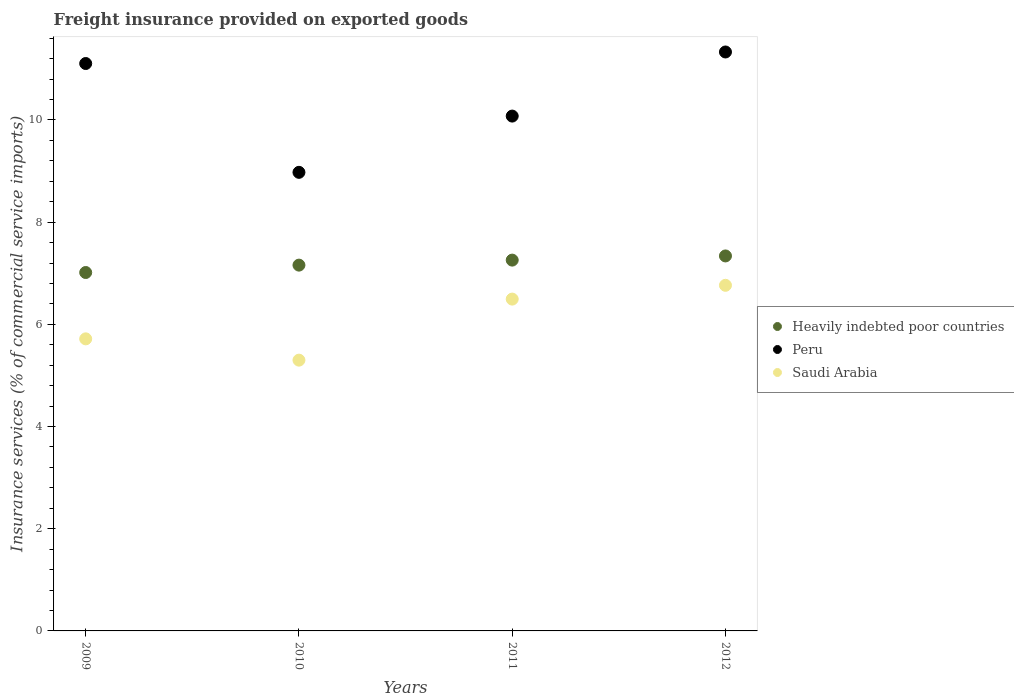How many different coloured dotlines are there?
Offer a very short reply. 3. Is the number of dotlines equal to the number of legend labels?
Offer a terse response. Yes. What is the freight insurance provided on exported goods in Peru in 2009?
Your response must be concise. 11.1. Across all years, what is the maximum freight insurance provided on exported goods in Heavily indebted poor countries?
Offer a very short reply. 7.34. Across all years, what is the minimum freight insurance provided on exported goods in Peru?
Keep it short and to the point. 8.98. In which year was the freight insurance provided on exported goods in Heavily indebted poor countries minimum?
Your response must be concise. 2009. What is the total freight insurance provided on exported goods in Saudi Arabia in the graph?
Give a very brief answer. 24.27. What is the difference between the freight insurance provided on exported goods in Peru in 2011 and that in 2012?
Give a very brief answer. -1.25. What is the difference between the freight insurance provided on exported goods in Saudi Arabia in 2011 and the freight insurance provided on exported goods in Heavily indebted poor countries in 2012?
Your response must be concise. -0.84. What is the average freight insurance provided on exported goods in Saudi Arabia per year?
Offer a very short reply. 6.07. In the year 2011, what is the difference between the freight insurance provided on exported goods in Peru and freight insurance provided on exported goods in Heavily indebted poor countries?
Provide a succinct answer. 2.82. What is the ratio of the freight insurance provided on exported goods in Peru in 2009 to that in 2011?
Provide a short and direct response. 1.1. What is the difference between the highest and the second highest freight insurance provided on exported goods in Peru?
Give a very brief answer. 0.23. What is the difference between the highest and the lowest freight insurance provided on exported goods in Peru?
Your response must be concise. 2.36. In how many years, is the freight insurance provided on exported goods in Saudi Arabia greater than the average freight insurance provided on exported goods in Saudi Arabia taken over all years?
Provide a short and direct response. 2. Is it the case that in every year, the sum of the freight insurance provided on exported goods in Peru and freight insurance provided on exported goods in Saudi Arabia  is greater than the freight insurance provided on exported goods in Heavily indebted poor countries?
Provide a succinct answer. Yes. Does the freight insurance provided on exported goods in Peru monotonically increase over the years?
Your response must be concise. No. Is the freight insurance provided on exported goods in Peru strictly less than the freight insurance provided on exported goods in Heavily indebted poor countries over the years?
Offer a very short reply. No. How many dotlines are there?
Provide a succinct answer. 3. What is the difference between two consecutive major ticks on the Y-axis?
Give a very brief answer. 2. Does the graph contain any zero values?
Make the answer very short. No. Where does the legend appear in the graph?
Offer a very short reply. Center right. How are the legend labels stacked?
Your answer should be very brief. Vertical. What is the title of the graph?
Your response must be concise. Freight insurance provided on exported goods. Does "Guam" appear as one of the legend labels in the graph?
Your response must be concise. No. What is the label or title of the Y-axis?
Give a very brief answer. Insurance services (% of commercial service imports). What is the Insurance services (% of commercial service imports) in Heavily indebted poor countries in 2009?
Provide a succinct answer. 7.01. What is the Insurance services (% of commercial service imports) of Peru in 2009?
Your answer should be compact. 11.1. What is the Insurance services (% of commercial service imports) of Saudi Arabia in 2009?
Your answer should be very brief. 5.72. What is the Insurance services (% of commercial service imports) in Heavily indebted poor countries in 2010?
Your answer should be compact. 7.16. What is the Insurance services (% of commercial service imports) of Peru in 2010?
Give a very brief answer. 8.98. What is the Insurance services (% of commercial service imports) in Saudi Arabia in 2010?
Your answer should be compact. 5.3. What is the Insurance services (% of commercial service imports) in Heavily indebted poor countries in 2011?
Offer a terse response. 7.26. What is the Insurance services (% of commercial service imports) of Peru in 2011?
Make the answer very short. 10.08. What is the Insurance services (% of commercial service imports) of Saudi Arabia in 2011?
Make the answer very short. 6.49. What is the Insurance services (% of commercial service imports) in Heavily indebted poor countries in 2012?
Make the answer very short. 7.34. What is the Insurance services (% of commercial service imports) of Peru in 2012?
Give a very brief answer. 11.33. What is the Insurance services (% of commercial service imports) of Saudi Arabia in 2012?
Provide a succinct answer. 6.76. Across all years, what is the maximum Insurance services (% of commercial service imports) in Heavily indebted poor countries?
Give a very brief answer. 7.34. Across all years, what is the maximum Insurance services (% of commercial service imports) of Peru?
Your answer should be compact. 11.33. Across all years, what is the maximum Insurance services (% of commercial service imports) of Saudi Arabia?
Your answer should be compact. 6.76. Across all years, what is the minimum Insurance services (% of commercial service imports) in Heavily indebted poor countries?
Your answer should be compact. 7.01. Across all years, what is the minimum Insurance services (% of commercial service imports) in Peru?
Provide a succinct answer. 8.98. Across all years, what is the minimum Insurance services (% of commercial service imports) in Saudi Arabia?
Give a very brief answer. 5.3. What is the total Insurance services (% of commercial service imports) in Heavily indebted poor countries in the graph?
Offer a terse response. 28.77. What is the total Insurance services (% of commercial service imports) in Peru in the graph?
Keep it short and to the point. 41.49. What is the total Insurance services (% of commercial service imports) in Saudi Arabia in the graph?
Ensure brevity in your answer.  24.27. What is the difference between the Insurance services (% of commercial service imports) in Heavily indebted poor countries in 2009 and that in 2010?
Provide a short and direct response. -0.14. What is the difference between the Insurance services (% of commercial service imports) of Peru in 2009 and that in 2010?
Offer a very short reply. 2.13. What is the difference between the Insurance services (% of commercial service imports) of Saudi Arabia in 2009 and that in 2010?
Offer a very short reply. 0.42. What is the difference between the Insurance services (% of commercial service imports) of Heavily indebted poor countries in 2009 and that in 2011?
Your answer should be compact. -0.24. What is the difference between the Insurance services (% of commercial service imports) of Peru in 2009 and that in 2011?
Offer a terse response. 1.03. What is the difference between the Insurance services (% of commercial service imports) of Saudi Arabia in 2009 and that in 2011?
Ensure brevity in your answer.  -0.78. What is the difference between the Insurance services (% of commercial service imports) of Heavily indebted poor countries in 2009 and that in 2012?
Ensure brevity in your answer.  -0.32. What is the difference between the Insurance services (% of commercial service imports) in Peru in 2009 and that in 2012?
Provide a succinct answer. -0.23. What is the difference between the Insurance services (% of commercial service imports) in Saudi Arabia in 2009 and that in 2012?
Keep it short and to the point. -1.05. What is the difference between the Insurance services (% of commercial service imports) in Heavily indebted poor countries in 2010 and that in 2011?
Your response must be concise. -0.1. What is the difference between the Insurance services (% of commercial service imports) in Peru in 2010 and that in 2011?
Offer a terse response. -1.1. What is the difference between the Insurance services (% of commercial service imports) in Saudi Arabia in 2010 and that in 2011?
Your answer should be very brief. -1.19. What is the difference between the Insurance services (% of commercial service imports) of Heavily indebted poor countries in 2010 and that in 2012?
Your answer should be compact. -0.18. What is the difference between the Insurance services (% of commercial service imports) in Peru in 2010 and that in 2012?
Your answer should be compact. -2.36. What is the difference between the Insurance services (% of commercial service imports) in Saudi Arabia in 2010 and that in 2012?
Keep it short and to the point. -1.46. What is the difference between the Insurance services (% of commercial service imports) in Heavily indebted poor countries in 2011 and that in 2012?
Give a very brief answer. -0.08. What is the difference between the Insurance services (% of commercial service imports) of Peru in 2011 and that in 2012?
Offer a terse response. -1.25. What is the difference between the Insurance services (% of commercial service imports) of Saudi Arabia in 2011 and that in 2012?
Offer a terse response. -0.27. What is the difference between the Insurance services (% of commercial service imports) of Heavily indebted poor countries in 2009 and the Insurance services (% of commercial service imports) of Peru in 2010?
Provide a short and direct response. -1.96. What is the difference between the Insurance services (% of commercial service imports) of Heavily indebted poor countries in 2009 and the Insurance services (% of commercial service imports) of Saudi Arabia in 2010?
Offer a very short reply. 1.72. What is the difference between the Insurance services (% of commercial service imports) of Peru in 2009 and the Insurance services (% of commercial service imports) of Saudi Arabia in 2010?
Keep it short and to the point. 5.81. What is the difference between the Insurance services (% of commercial service imports) in Heavily indebted poor countries in 2009 and the Insurance services (% of commercial service imports) in Peru in 2011?
Offer a very short reply. -3.06. What is the difference between the Insurance services (% of commercial service imports) of Heavily indebted poor countries in 2009 and the Insurance services (% of commercial service imports) of Saudi Arabia in 2011?
Make the answer very short. 0.52. What is the difference between the Insurance services (% of commercial service imports) of Peru in 2009 and the Insurance services (% of commercial service imports) of Saudi Arabia in 2011?
Provide a succinct answer. 4.61. What is the difference between the Insurance services (% of commercial service imports) of Heavily indebted poor countries in 2009 and the Insurance services (% of commercial service imports) of Peru in 2012?
Your response must be concise. -4.32. What is the difference between the Insurance services (% of commercial service imports) in Heavily indebted poor countries in 2009 and the Insurance services (% of commercial service imports) in Saudi Arabia in 2012?
Keep it short and to the point. 0.25. What is the difference between the Insurance services (% of commercial service imports) in Peru in 2009 and the Insurance services (% of commercial service imports) in Saudi Arabia in 2012?
Keep it short and to the point. 4.34. What is the difference between the Insurance services (% of commercial service imports) in Heavily indebted poor countries in 2010 and the Insurance services (% of commercial service imports) in Peru in 2011?
Your answer should be compact. -2.92. What is the difference between the Insurance services (% of commercial service imports) of Heavily indebted poor countries in 2010 and the Insurance services (% of commercial service imports) of Saudi Arabia in 2011?
Make the answer very short. 0.66. What is the difference between the Insurance services (% of commercial service imports) of Peru in 2010 and the Insurance services (% of commercial service imports) of Saudi Arabia in 2011?
Your answer should be very brief. 2.48. What is the difference between the Insurance services (% of commercial service imports) of Heavily indebted poor countries in 2010 and the Insurance services (% of commercial service imports) of Peru in 2012?
Your answer should be very brief. -4.17. What is the difference between the Insurance services (% of commercial service imports) in Heavily indebted poor countries in 2010 and the Insurance services (% of commercial service imports) in Saudi Arabia in 2012?
Keep it short and to the point. 0.4. What is the difference between the Insurance services (% of commercial service imports) in Peru in 2010 and the Insurance services (% of commercial service imports) in Saudi Arabia in 2012?
Offer a very short reply. 2.21. What is the difference between the Insurance services (% of commercial service imports) of Heavily indebted poor countries in 2011 and the Insurance services (% of commercial service imports) of Peru in 2012?
Offer a terse response. -4.07. What is the difference between the Insurance services (% of commercial service imports) of Heavily indebted poor countries in 2011 and the Insurance services (% of commercial service imports) of Saudi Arabia in 2012?
Give a very brief answer. 0.49. What is the difference between the Insurance services (% of commercial service imports) of Peru in 2011 and the Insurance services (% of commercial service imports) of Saudi Arabia in 2012?
Provide a short and direct response. 3.31. What is the average Insurance services (% of commercial service imports) in Heavily indebted poor countries per year?
Your answer should be compact. 7.19. What is the average Insurance services (% of commercial service imports) of Peru per year?
Make the answer very short. 10.37. What is the average Insurance services (% of commercial service imports) of Saudi Arabia per year?
Your answer should be very brief. 6.07. In the year 2009, what is the difference between the Insurance services (% of commercial service imports) of Heavily indebted poor countries and Insurance services (% of commercial service imports) of Peru?
Provide a short and direct response. -4.09. In the year 2009, what is the difference between the Insurance services (% of commercial service imports) of Heavily indebted poor countries and Insurance services (% of commercial service imports) of Saudi Arabia?
Provide a short and direct response. 1.3. In the year 2009, what is the difference between the Insurance services (% of commercial service imports) of Peru and Insurance services (% of commercial service imports) of Saudi Arabia?
Offer a very short reply. 5.39. In the year 2010, what is the difference between the Insurance services (% of commercial service imports) of Heavily indebted poor countries and Insurance services (% of commercial service imports) of Peru?
Your answer should be very brief. -1.82. In the year 2010, what is the difference between the Insurance services (% of commercial service imports) in Heavily indebted poor countries and Insurance services (% of commercial service imports) in Saudi Arabia?
Your response must be concise. 1.86. In the year 2010, what is the difference between the Insurance services (% of commercial service imports) of Peru and Insurance services (% of commercial service imports) of Saudi Arabia?
Offer a very short reply. 3.68. In the year 2011, what is the difference between the Insurance services (% of commercial service imports) of Heavily indebted poor countries and Insurance services (% of commercial service imports) of Peru?
Ensure brevity in your answer.  -2.82. In the year 2011, what is the difference between the Insurance services (% of commercial service imports) in Heavily indebted poor countries and Insurance services (% of commercial service imports) in Saudi Arabia?
Your response must be concise. 0.76. In the year 2011, what is the difference between the Insurance services (% of commercial service imports) of Peru and Insurance services (% of commercial service imports) of Saudi Arabia?
Provide a succinct answer. 3.58. In the year 2012, what is the difference between the Insurance services (% of commercial service imports) of Heavily indebted poor countries and Insurance services (% of commercial service imports) of Peru?
Provide a short and direct response. -3.99. In the year 2012, what is the difference between the Insurance services (% of commercial service imports) of Heavily indebted poor countries and Insurance services (% of commercial service imports) of Saudi Arabia?
Provide a short and direct response. 0.57. In the year 2012, what is the difference between the Insurance services (% of commercial service imports) in Peru and Insurance services (% of commercial service imports) in Saudi Arabia?
Make the answer very short. 4.57. What is the ratio of the Insurance services (% of commercial service imports) of Heavily indebted poor countries in 2009 to that in 2010?
Your response must be concise. 0.98. What is the ratio of the Insurance services (% of commercial service imports) of Peru in 2009 to that in 2010?
Make the answer very short. 1.24. What is the ratio of the Insurance services (% of commercial service imports) of Saudi Arabia in 2009 to that in 2010?
Your answer should be very brief. 1.08. What is the ratio of the Insurance services (% of commercial service imports) of Heavily indebted poor countries in 2009 to that in 2011?
Offer a terse response. 0.97. What is the ratio of the Insurance services (% of commercial service imports) in Peru in 2009 to that in 2011?
Offer a very short reply. 1.1. What is the ratio of the Insurance services (% of commercial service imports) in Saudi Arabia in 2009 to that in 2011?
Your response must be concise. 0.88. What is the ratio of the Insurance services (% of commercial service imports) of Heavily indebted poor countries in 2009 to that in 2012?
Provide a succinct answer. 0.96. What is the ratio of the Insurance services (% of commercial service imports) of Peru in 2009 to that in 2012?
Provide a succinct answer. 0.98. What is the ratio of the Insurance services (% of commercial service imports) in Saudi Arabia in 2009 to that in 2012?
Provide a short and direct response. 0.85. What is the ratio of the Insurance services (% of commercial service imports) in Heavily indebted poor countries in 2010 to that in 2011?
Your response must be concise. 0.99. What is the ratio of the Insurance services (% of commercial service imports) in Peru in 2010 to that in 2011?
Keep it short and to the point. 0.89. What is the ratio of the Insurance services (% of commercial service imports) of Saudi Arabia in 2010 to that in 2011?
Make the answer very short. 0.82. What is the ratio of the Insurance services (% of commercial service imports) of Heavily indebted poor countries in 2010 to that in 2012?
Keep it short and to the point. 0.98. What is the ratio of the Insurance services (% of commercial service imports) of Peru in 2010 to that in 2012?
Provide a succinct answer. 0.79. What is the ratio of the Insurance services (% of commercial service imports) in Saudi Arabia in 2010 to that in 2012?
Give a very brief answer. 0.78. What is the ratio of the Insurance services (% of commercial service imports) of Heavily indebted poor countries in 2011 to that in 2012?
Keep it short and to the point. 0.99. What is the ratio of the Insurance services (% of commercial service imports) in Peru in 2011 to that in 2012?
Provide a succinct answer. 0.89. What is the ratio of the Insurance services (% of commercial service imports) of Saudi Arabia in 2011 to that in 2012?
Ensure brevity in your answer.  0.96. What is the difference between the highest and the second highest Insurance services (% of commercial service imports) in Heavily indebted poor countries?
Offer a very short reply. 0.08. What is the difference between the highest and the second highest Insurance services (% of commercial service imports) of Peru?
Offer a very short reply. 0.23. What is the difference between the highest and the second highest Insurance services (% of commercial service imports) of Saudi Arabia?
Your answer should be compact. 0.27. What is the difference between the highest and the lowest Insurance services (% of commercial service imports) of Heavily indebted poor countries?
Offer a terse response. 0.32. What is the difference between the highest and the lowest Insurance services (% of commercial service imports) in Peru?
Your answer should be compact. 2.36. What is the difference between the highest and the lowest Insurance services (% of commercial service imports) in Saudi Arabia?
Offer a very short reply. 1.46. 